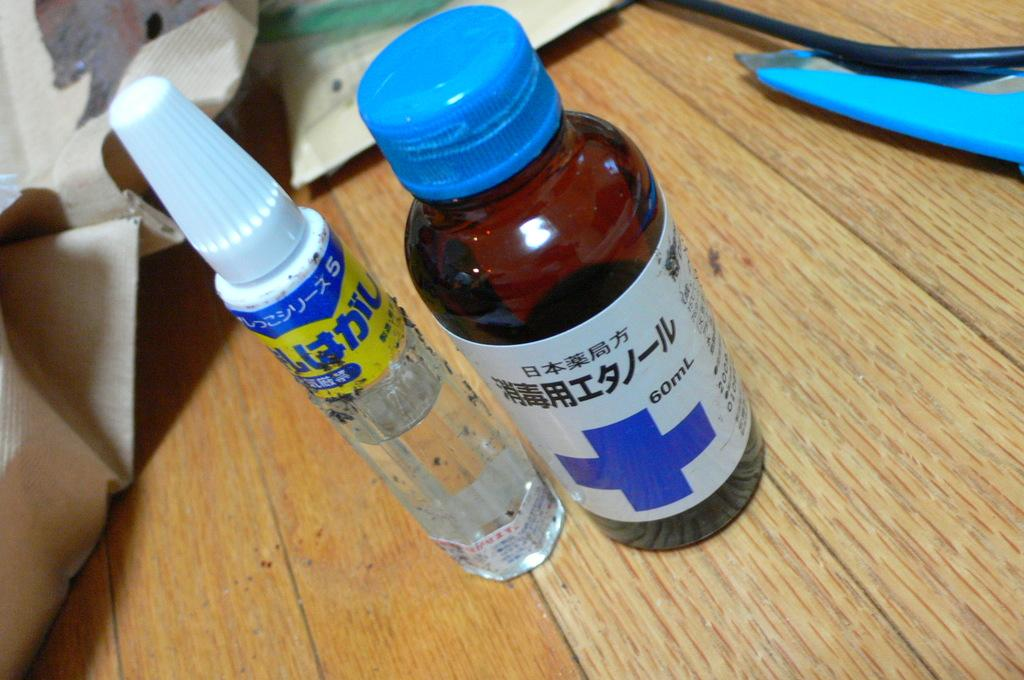<image>
Provide a brief description of the given image. Small bottle at 60mL with a blue cap on it. 